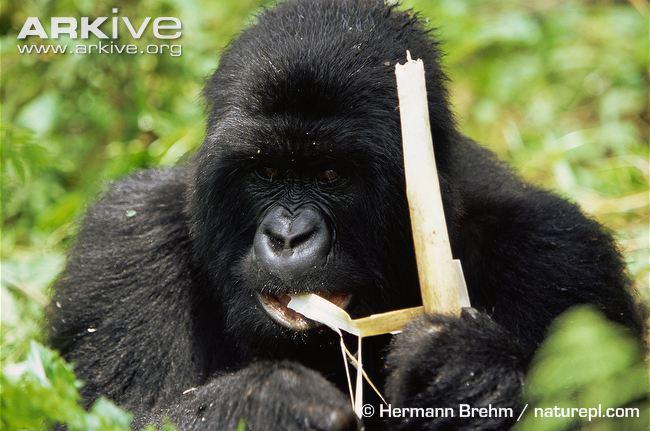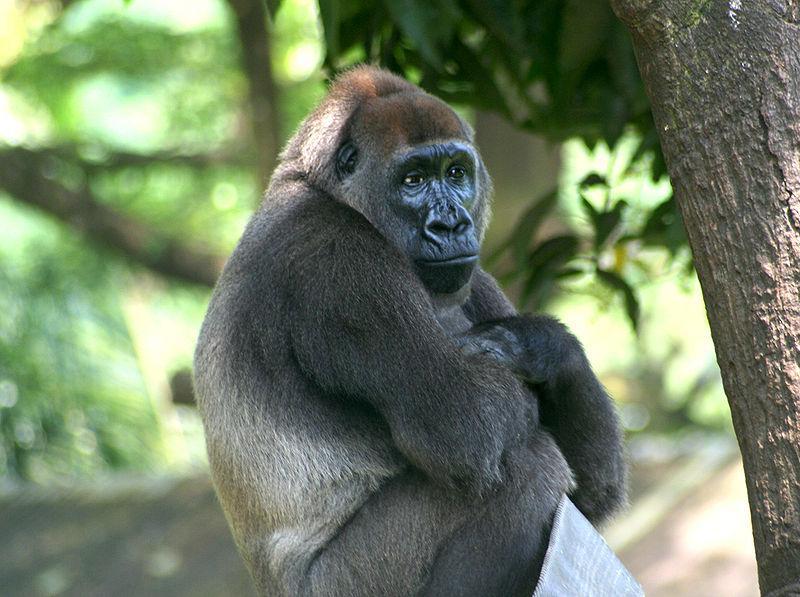The first image is the image on the left, the second image is the image on the right. Analyze the images presented: Is the assertion "There are three gorillas" valid? Answer yes or no. No. 